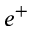<formula> <loc_0><loc_0><loc_500><loc_500>e ^ { + }</formula> 